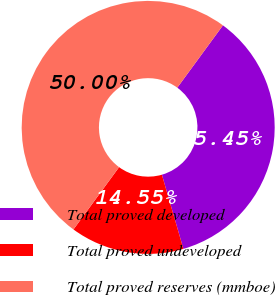Convert chart to OTSL. <chart><loc_0><loc_0><loc_500><loc_500><pie_chart><fcel>Total proved developed<fcel>Total proved undeveloped<fcel>Total proved reserves (mmboe)<nl><fcel>35.45%<fcel>14.55%<fcel>50.0%<nl></chart> 